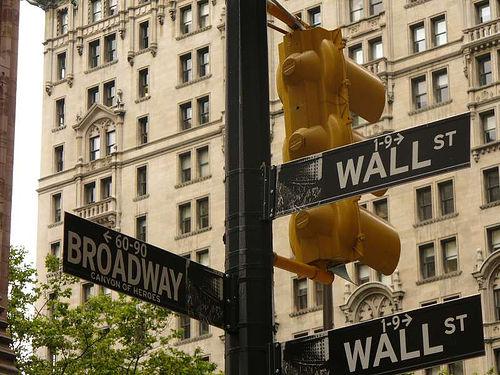What is city is this?
Quick response, please. New york. What season is it?
Give a very brief answer. Spring. How many unique street signs are there?
Give a very brief answer. 2. 